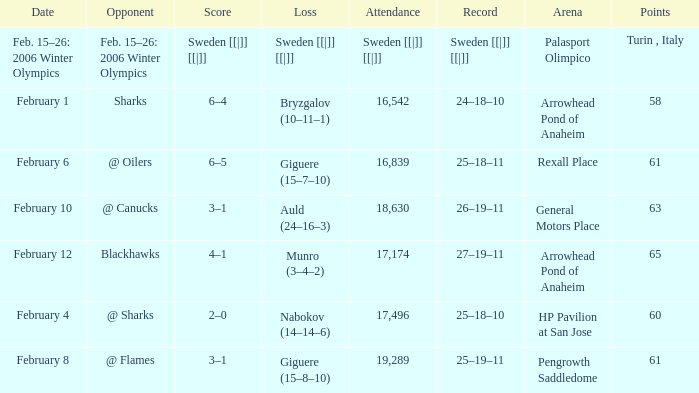What is the Arena when there were 65 points? Arrowhead Pond of Anaheim. 